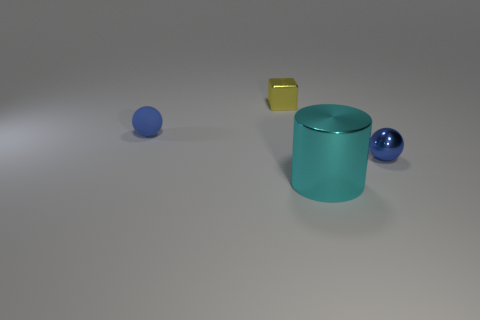Add 3 cyan things. How many objects exist? 7 Subtract all cylinders. How many objects are left? 3 Subtract all small metallic things. Subtract all large metal things. How many objects are left? 1 Add 3 yellow shiny blocks. How many yellow shiny blocks are left? 4 Add 1 purple rubber cubes. How many purple rubber cubes exist? 1 Subtract 0 brown cubes. How many objects are left? 4 